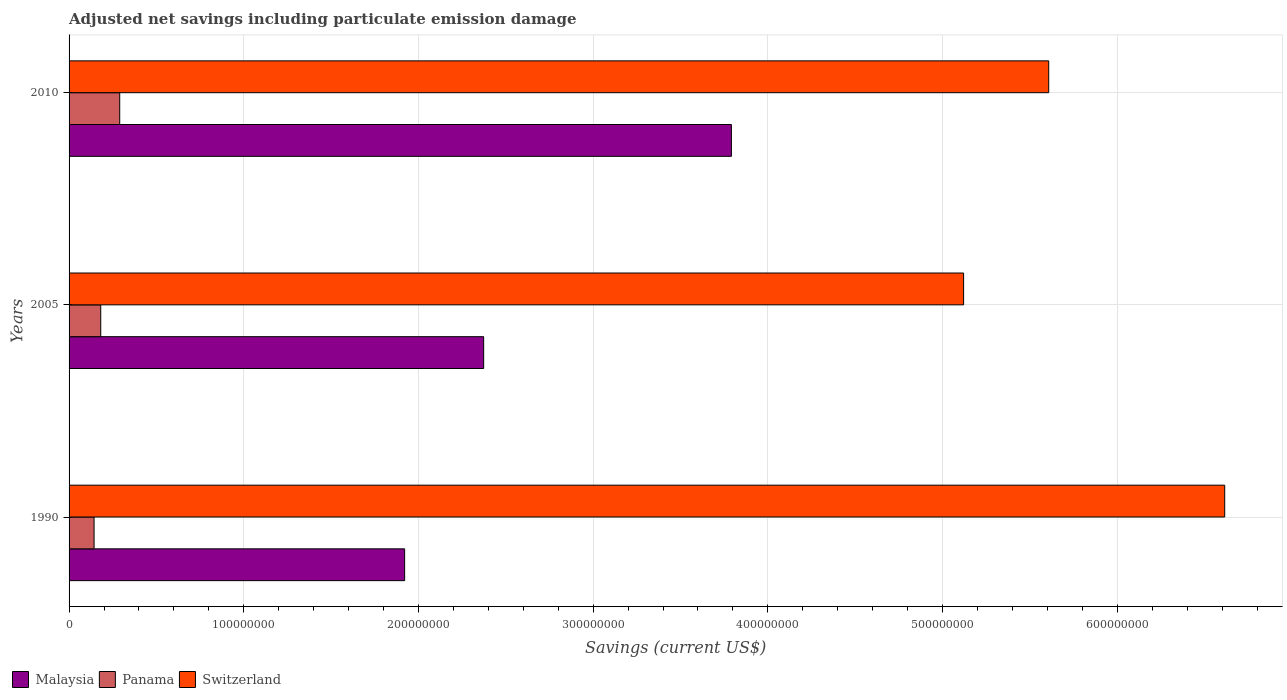How many groups of bars are there?
Provide a succinct answer. 3. Are the number of bars per tick equal to the number of legend labels?
Keep it short and to the point. Yes. How many bars are there on the 2nd tick from the bottom?
Keep it short and to the point. 3. What is the net savings in Switzerland in 2005?
Your answer should be compact. 5.12e+08. Across all years, what is the maximum net savings in Panama?
Your answer should be very brief. 2.90e+07. Across all years, what is the minimum net savings in Panama?
Keep it short and to the point. 1.43e+07. What is the total net savings in Panama in the graph?
Offer a terse response. 6.14e+07. What is the difference between the net savings in Malaysia in 1990 and that in 2005?
Your answer should be compact. -4.52e+07. What is the difference between the net savings in Malaysia in 1990 and the net savings in Panama in 2010?
Provide a succinct answer. 1.63e+08. What is the average net savings in Switzerland per year?
Ensure brevity in your answer.  5.78e+08. In the year 1990, what is the difference between the net savings in Panama and net savings in Switzerland?
Your response must be concise. -6.47e+08. In how many years, is the net savings in Malaysia greater than 440000000 US$?
Make the answer very short. 0. What is the ratio of the net savings in Panama in 1990 to that in 2010?
Provide a short and direct response. 0.49. What is the difference between the highest and the second highest net savings in Switzerland?
Make the answer very short. 1.01e+08. What is the difference between the highest and the lowest net savings in Switzerland?
Your answer should be very brief. 1.49e+08. Is the sum of the net savings in Switzerland in 2005 and 2010 greater than the maximum net savings in Panama across all years?
Your answer should be very brief. Yes. What does the 1st bar from the top in 2010 represents?
Offer a very short reply. Switzerland. What does the 3rd bar from the bottom in 2010 represents?
Give a very brief answer. Switzerland. Is it the case that in every year, the sum of the net savings in Switzerland and net savings in Malaysia is greater than the net savings in Panama?
Give a very brief answer. Yes. Are the values on the major ticks of X-axis written in scientific E-notation?
Make the answer very short. No. Where does the legend appear in the graph?
Make the answer very short. Bottom left. How many legend labels are there?
Give a very brief answer. 3. How are the legend labels stacked?
Keep it short and to the point. Horizontal. What is the title of the graph?
Keep it short and to the point. Adjusted net savings including particulate emission damage. What is the label or title of the X-axis?
Provide a succinct answer. Savings (current US$). What is the Savings (current US$) in Malaysia in 1990?
Provide a short and direct response. 1.92e+08. What is the Savings (current US$) of Panama in 1990?
Ensure brevity in your answer.  1.43e+07. What is the Savings (current US$) in Switzerland in 1990?
Make the answer very short. 6.61e+08. What is the Savings (current US$) in Malaysia in 2005?
Provide a succinct answer. 2.37e+08. What is the Savings (current US$) of Panama in 2005?
Ensure brevity in your answer.  1.81e+07. What is the Savings (current US$) of Switzerland in 2005?
Keep it short and to the point. 5.12e+08. What is the Savings (current US$) in Malaysia in 2010?
Keep it short and to the point. 3.79e+08. What is the Savings (current US$) in Panama in 2010?
Keep it short and to the point. 2.90e+07. What is the Savings (current US$) of Switzerland in 2010?
Your response must be concise. 5.61e+08. Across all years, what is the maximum Savings (current US$) of Malaysia?
Offer a terse response. 3.79e+08. Across all years, what is the maximum Savings (current US$) in Panama?
Ensure brevity in your answer.  2.90e+07. Across all years, what is the maximum Savings (current US$) in Switzerland?
Provide a short and direct response. 6.61e+08. Across all years, what is the minimum Savings (current US$) of Malaysia?
Your answer should be very brief. 1.92e+08. Across all years, what is the minimum Savings (current US$) of Panama?
Provide a succinct answer. 1.43e+07. Across all years, what is the minimum Savings (current US$) of Switzerland?
Make the answer very short. 5.12e+08. What is the total Savings (current US$) of Malaysia in the graph?
Provide a succinct answer. 8.09e+08. What is the total Savings (current US$) in Panama in the graph?
Make the answer very short. 6.14e+07. What is the total Savings (current US$) of Switzerland in the graph?
Provide a short and direct response. 1.73e+09. What is the difference between the Savings (current US$) of Malaysia in 1990 and that in 2005?
Your response must be concise. -4.52e+07. What is the difference between the Savings (current US$) of Panama in 1990 and that in 2005?
Your answer should be compact. -3.82e+06. What is the difference between the Savings (current US$) in Switzerland in 1990 and that in 2005?
Keep it short and to the point. 1.49e+08. What is the difference between the Savings (current US$) of Malaysia in 1990 and that in 2010?
Your response must be concise. -1.87e+08. What is the difference between the Savings (current US$) of Panama in 1990 and that in 2010?
Keep it short and to the point. -1.47e+07. What is the difference between the Savings (current US$) in Switzerland in 1990 and that in 2010?
Ensure brevity in your answer.  1.01e+08. What is the difference between the Savings (current US$) in Malaysia in 2005 and that in 2010?
Offer a terse response. -1.42e+08. What is the difference between the Savings (current US$) of Panama in 2005 and that in 2010?
Keep it short and to the point. -1.09e+07. What is the difference between the Savings (current US$) of Switzerland in 2005 and that in 2010?
Keep it short and to the point. -4.87e+07. What is the difference between the Savings (current US$) in Malaysia in 1990 and the Savings (current US$) in Panama in 2005?
Make the answer very short. 1.74e+08. What is the difference between the Savings (current US$) in Malaysia in 1990 and the Savings (current US$) in Switzerland in 2005?
Your response must be concise. -3.20e+08. What is the difference between the Savings (current US$) of Panama in 1990 and the Savings (current US$) of Switzerland in 2005?
Ensure brevity in your answer.  -4.98e+08. What is the difference between the Savings (current US$) of Malaysia in 1990 and the Savings (current US$) of Panama in 2010?
Provide a short and direct response. 1.63e+08. What is the difference between the Savings (current US$) of Malaysia in 1990 and the Savings (current US$) of Switzerland in 2010?
Provide a short and direct response. -3.69e+08. What is the difference between the Savings (current US$) in Panama in 1990 and the Savings (current US$) in Switzerland in 2010?
Offer a terse response. -5.46e+08. What is the difference between the Savings (current US$) of Malaysia in 2005 and the Savings (current US$) of Panama in 2010?
Give a very brief answer. 2.08e+08. What is the difference between the Savings (current US$) of Malaysia in 2005 and the Savings (current US$) of Switzerland in 2010?
Offer a very short reply. -3.23e+08. What is the difference between the Savings (current US$) of Panama in 2005 and the Savings (current US$) of Switzerland in 2010?
Give a very brief answer. -5.43e+08. What is the average Savings (current US$) in Malaysia per year?
Offer a very short reply. 2.70e+08. What is the average Savings (current US$) of Panama per year?
Keep it short and to the point. 2.05e+07. What is the average Savings (current US$) of Switzerland per year?
Provide a short and direct response. 5.78e+08. In the year 1990, what is the difference between the Savings (current US$) of Malaysia and Savings (current US$) of Panama?
Keep it short and to the point. 1.78e+08. In the year 1990, what is the difference between the Savings (current US$) of Malaysia and Savings (current US$) of Switzerland?
Offer a very short reply. -4.69e+08. In the year 1990, what is the difference between the Savings (current US$) of Panama and Savings (current US$) of Switzerland?
Offer a very short reply. -6.47e+08. In the year 2005, what is the difference between the Savings (current US$) in Malaysia and Savings (current US$) in Panama?
Your answer should be very brief. 2.19e+08. In the year 2005, what is the difference between the Savings (current US$) in Malaysia and Savings (current US$) in Switzerland?
Keep it short and to the point. -2.75e+08. In the year 2005, what is the difference between the Savings (current US$) of Panama and Savings (current US$) of Switzerland?
Your answer should be compact. -4.94e+08. In the year 2010, what is the difference between the Savings (current US$) of Malaysia and Savings (current US$) of Panama?
Give a very brief answer. 3.50e+08. In the year 2010, what is the difference between the Savings (current US$) of Malaysia and Savings (current US$) of Switzerland?
Offer a terse response. -1.82e+08. In the year 2010, what is the difference between the Savings (current US$) in Panama and Savings (current US$) in Switzerland?
Offer a terse response. -5.32e+08. What is the ratio of the Savings (current US$) of Malaysia in 1990 to that in 2005?
Provide a succinct answer. 0.81. What is the ratio of the Savings (current US$) in Panama in 1990 to that in 2005?
Provide a short and direct response. 0.79. What is the ratio of the Savings (current US$) in Switzerland in 1990 to that in 2005?
Your response must be concise. 1.29. What is the ratio of the Savings (current US$) of Malaysia in 1990 to that in 2010?
Provide a short and direct response. 0.51. What is the ratio of the Savings (current US$) in Panama in 1990 to that in 2010?
Keep it short and to the point. 0.49. What is the ratio of the Savings (current US$) of Switzerland in 1990 to that in 2010?
Provide a short and direct response. 1.18. What is the ratio of the Savings (current US$) in Malaysia in 2005 to that in 2010?
Offer a very short reply. 0.63. What is the ratio of the Savings (current US$) in Panama in 2005 to that in 2010?
Your answer should be very brief. 0.63. What is the ratio of the Savings (current US$) in Switzerland in 2005 to that in 2010?
Your response must be concise. 0.91. What is the difference between the highest and the second highest Savings (current US$) of Malaysia?
Your answer should be very brief. 1.42e+08. What is the difference between the highest and the second highest Savings (current US$) in Panama?
Your response must be concise. 1.09e+07. What is the difference between the highest and the second highest Savings (current US$) of Switzerland?
Keep it short and to the point. 1.01e+08. What is the difference between the highest and the lowest Savings (current US$) of Malaysia?
Offer a terse response. 1.87e+08. What is the difference between the highest and the lowest Savings (current US$) of Panama?
Give a very brief answer. 1.47e+07. What is the difference between the highest and the lowest Savings (current US$) of Switzerland?
Keep it short and to the point. 1.49e+08. 